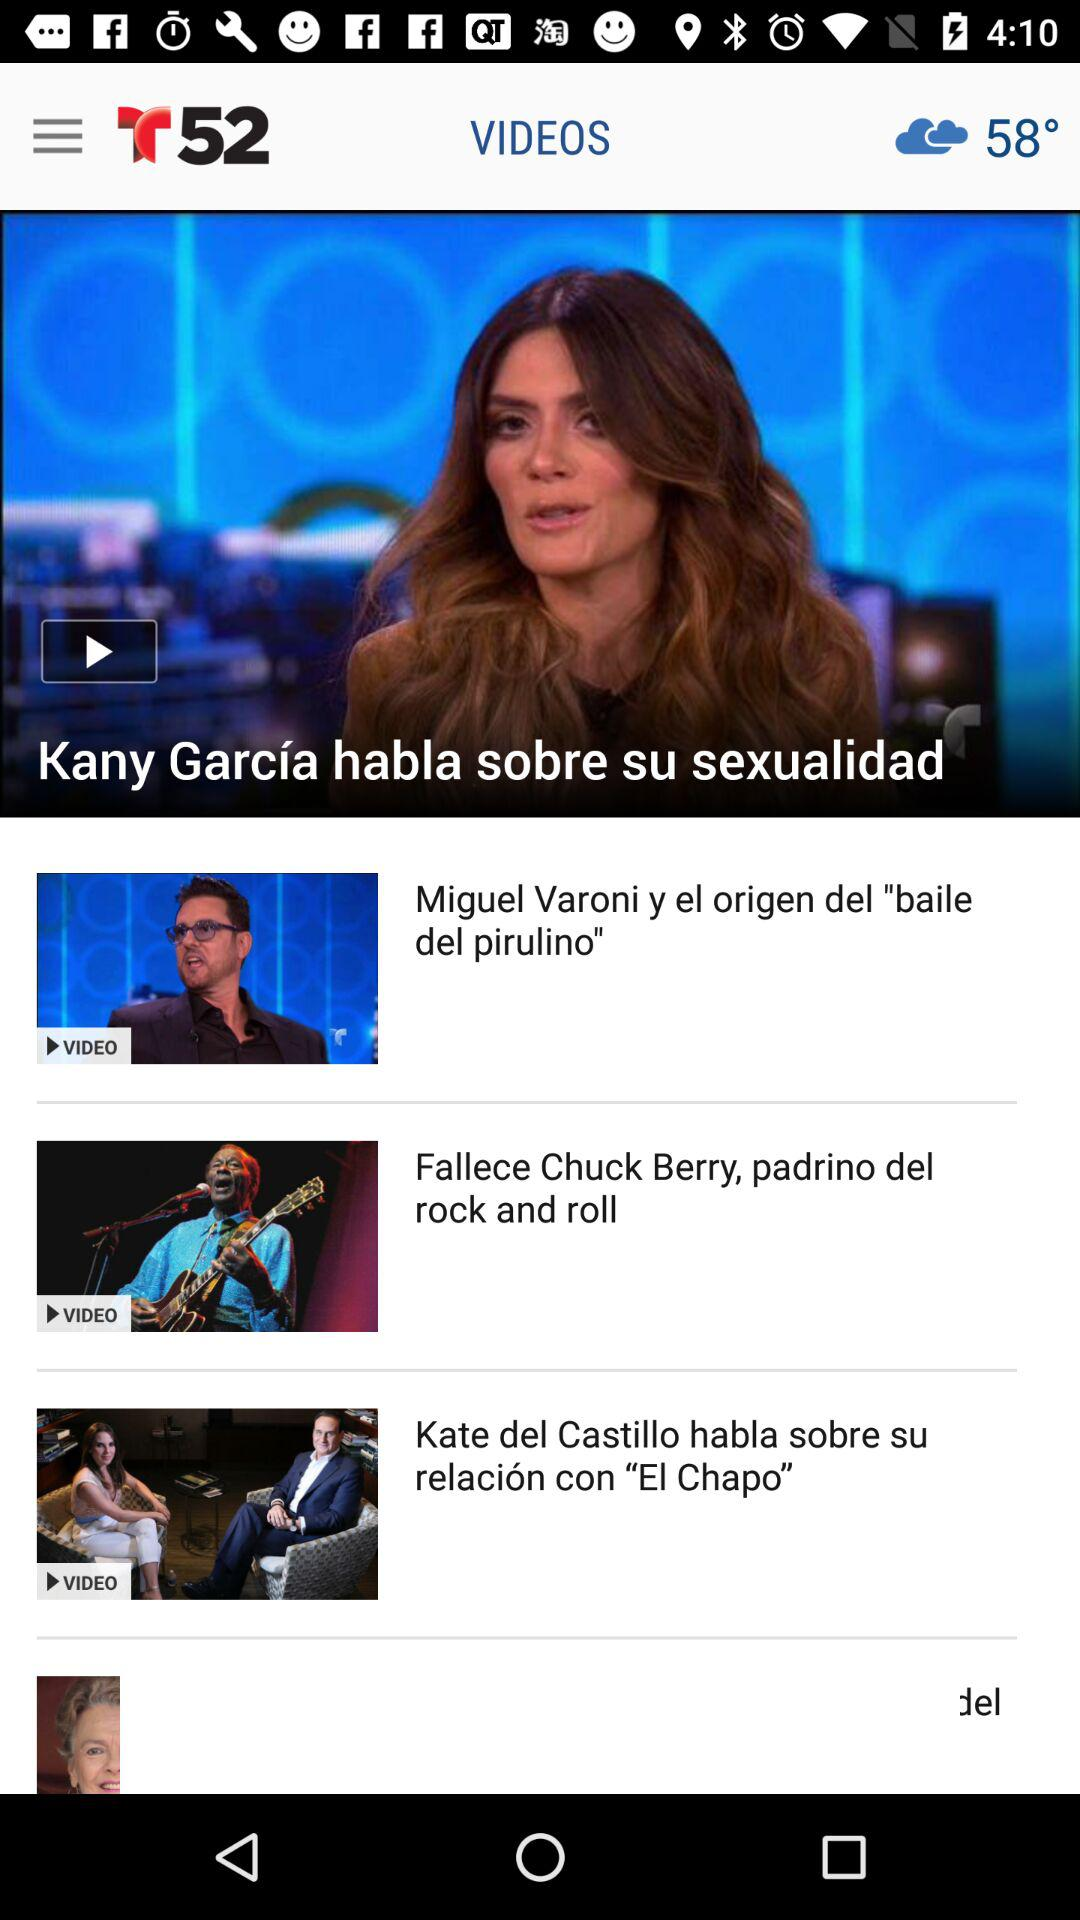How many videos are there in total?
Answer the question using a single word or phrase. 4 